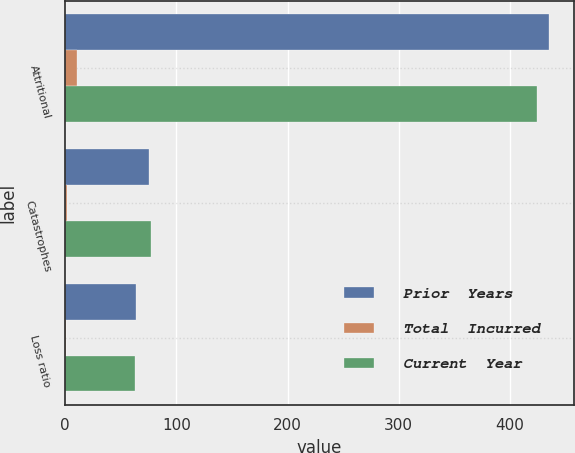<chart> <loc_0><loc_0><loc_500><loc_500><stacked_bar_chart><ecel><fcel>Attritional<fcel>Catastrophes<fcel>Loss ratio<nl><fcel>Prior  Years<fcel>435.6<fcel>75.4<fcel>63.6<nl><fcel>Total  Incurred<fcel>10.9<fcel>1.8<fcel>1.1<nl><fcel>Current  Year<fcel>424.7<fcel>77.2<fcel>62.4<nl></chart> 